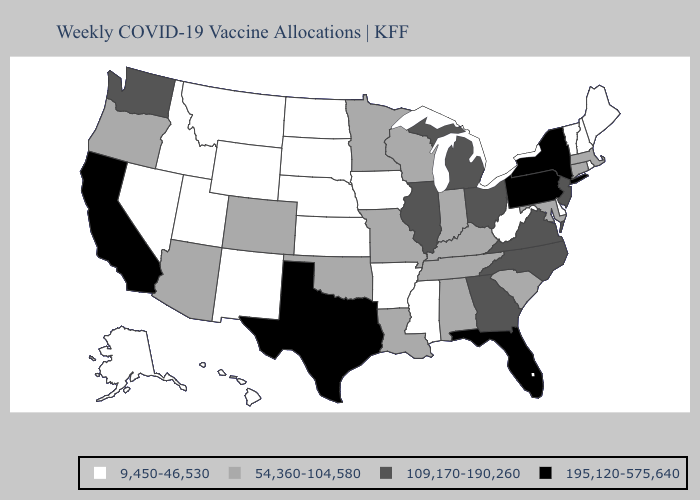What is the value of Kansas?
Be succinct. 9,450-46,530. What is the lowest value in the USA?
Short answer required. 9,450-46,530. Does Vermont have a lower value than North Dakota?
Write a very short answer. No. Name the states that have a value in the range 54,360-104,580?
Keep it brief. Alabama, Arizona, Colorado, Connecticut, Indiana, Kentucky, Louisiana, Maryland, Massachusetts, Minnesota, Missouri, Oklahoma, Oregon, South Carolina, Tennessee, Wisconsin. Among the states that border Indiana , does Kentucky have the highest value?
Keep it brief. No. Among the states that border New Mexico , which have the lowest value?
Be succinct. Utah. Does Texas have the highest value in the USA?
Write a very short answer. Yes. Does the first symbol in the legend represent the smallest category?
Keep it brief. Yes. Does Connecticut have a higher value than Maryland?
Concise answer only. No. What is the value of Washington?
Give a very brief answer. 109,170-190,260. What is the value of Colorado?
Be succinct. 54,360-104,580. Does the first symbol in the legend represent the smallest category?
Quick response, please. Yes. Does Texas have the same value as Florida?
Quick response, please. Yes. Name the states that have a value in the range 9,450-46,530?
Quick response, please. Alaska, Arkansas, Delaware, Hawaii, Idaho, Iowa, Kansas, Maine, Mississippi, Montana, Nebraska, Nevada, New Hampshire, New Mexico, North Dakota, Rhode Island, South Dakota, Utah, Vermont, West Virginia, Wyoming. Name the states that have a value in the range 9,450-46,530?
Be succinct. Alaska, Arkansas, Delaware, Hawaii, Idaho, Iowa, Kansas, Maine, Mississippi, Montana, Nebraska, Nevada, New Hampshire, New Mexico, North Dakota, Rhode Island, South Dakota, Utah, Vermont, West Virginia, Wyoming. 